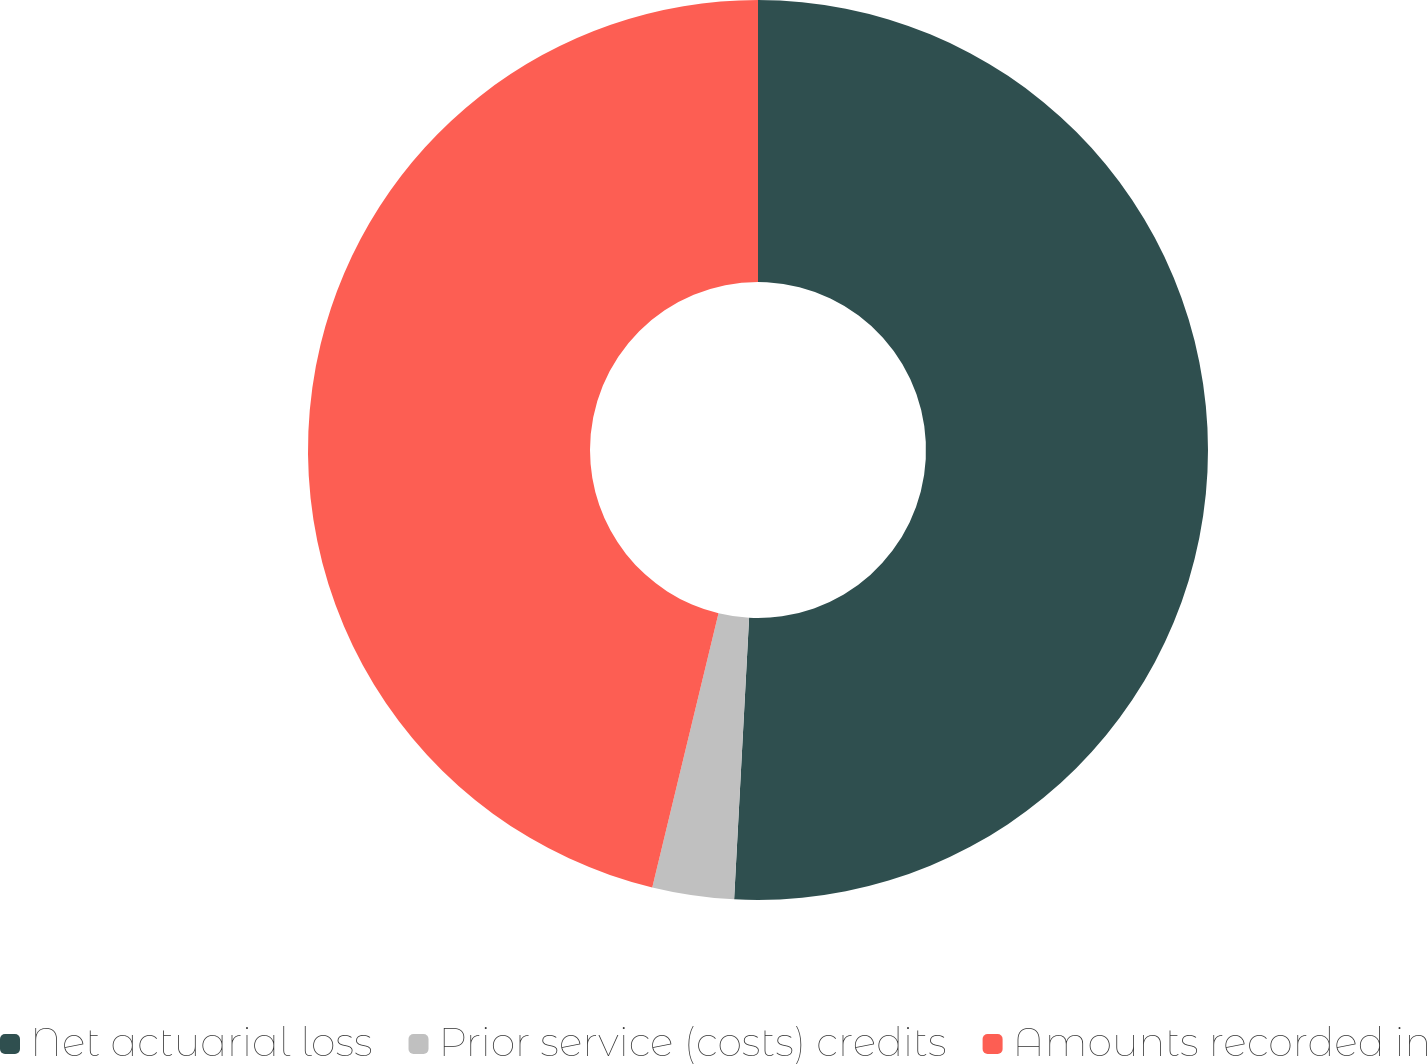Convert chart to OTSL. <chart><loc_0><loc_0><loc_500><loc_500><pie_chart><fcel>Net actuarial loss<fcel>Prior service (costs) credits<fcel>Amounts recorded in<nl><fcel>50.84%<fcel>2.93%<fcel>46.22%<nl></chart> 